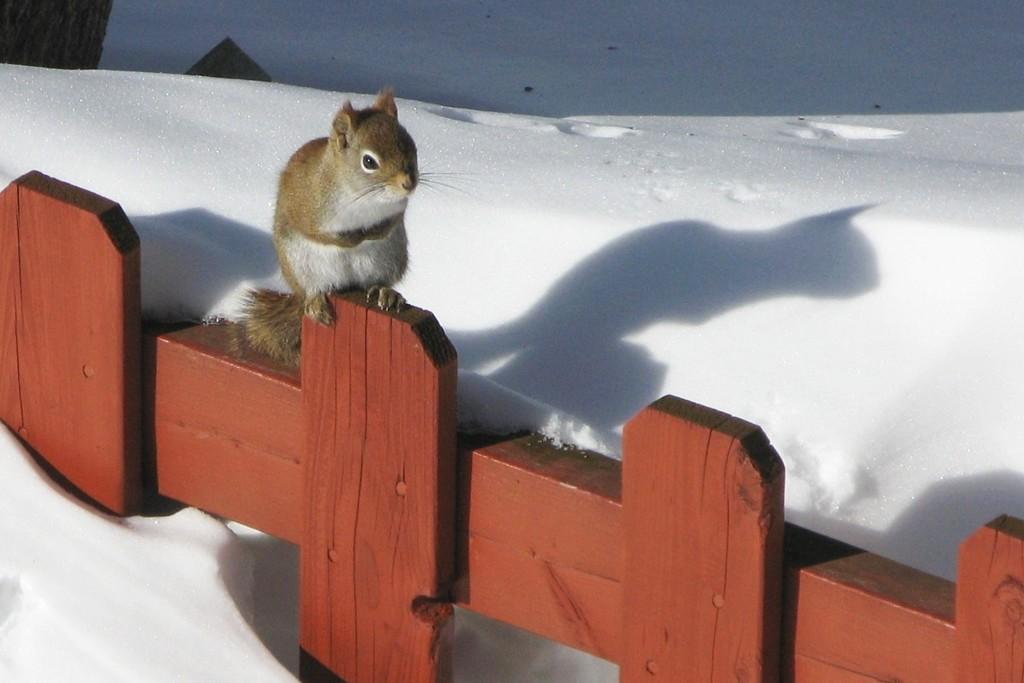What animal can be seen in the image? There is a squirrel in the image. Where is the squirrel sitting? The squirrel is sitting on a wooden fence. What type of weather is depicted in the image? There is snow at the bottom of the image, indicating a winter scene. What is located on the left side of the image? There is a tree on the left side of the image. How does the squirrel increase its self-awareness in the image? There is no indication in the image that the squirrel is increasing its self-awareness. What type of boot is the squirrel wearing in the image? There is no boot present in the image, as the squirrel is not wearing any footwear. 